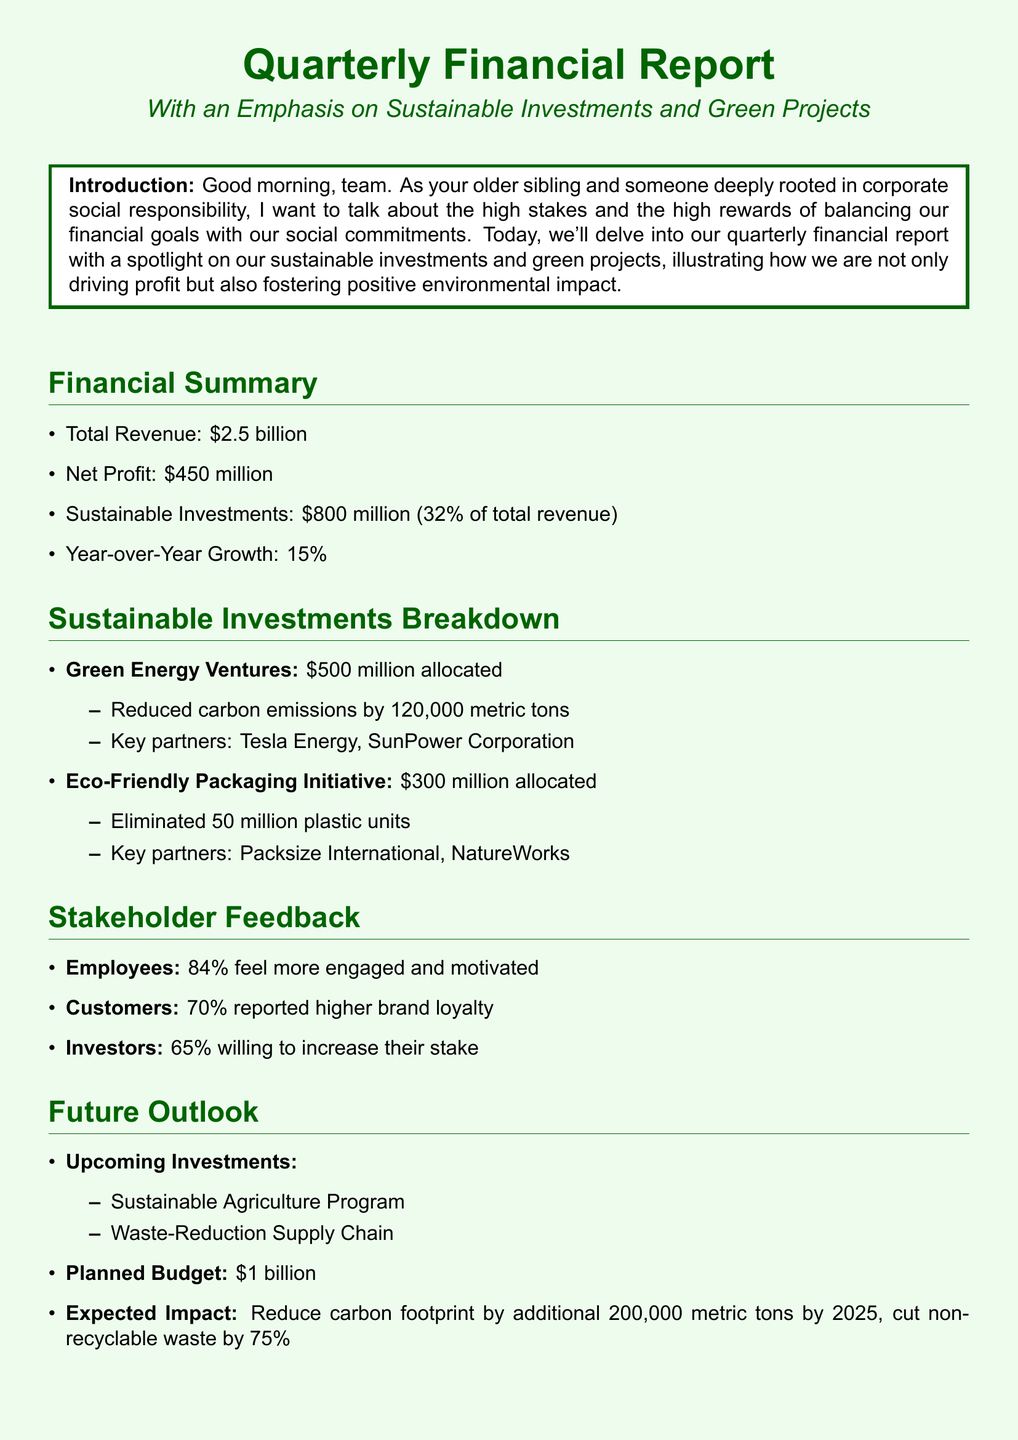What is the total revenue? The total revenue is explicitly stated in the financial summary section.
Answer: $2.5 billion What percentage of total revenue is allocated to sustainable investments? The percentage can be calculated from the sustainable investments provided in relation to total revenue.
Answer: 32% How much has been allocated to the Green Energy Ventures? The specific allocation amount is listed under the sustainable investments breakdown.
Answer: $500 million What is the expected impact on carbon footprint by 2025? The expected impact is mentioned in the future outlook section as a reduction in carbon footprint.
Answer: 200,000 metric tons What proportion of employees feel more engaged and motivated? This information is provided in the stakeholder feedback section regarding employee sentiment.
Answer: 84% Which company is a key partner in the Eco-Friendly Packaging Initiative? The document names a key partner linked to the Eco-Friendly Packaging Initiative.
Answer: NatureWorks What is the planned budget for upcoming investments? This budget is specifically mentioned in the future outlook section of the document.
Answer: $1 billion What is the year-over-year growth rate mentioned in the report? The growth rate is detailed in the financial summary section, indicating growth for the year.
Answer: 15% What type of future program is listed for upcoming investments? The document outlines specific types of upcoming investments in the future outlook section.
Answer: Sustainable Agriculture Program 